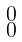Convert formula to latex. <formula><loc_0><loc_0><loc_500><loc_500>\begin{smallmatrix} 0 \\ 0 \end{smallmatrix}</formula> 